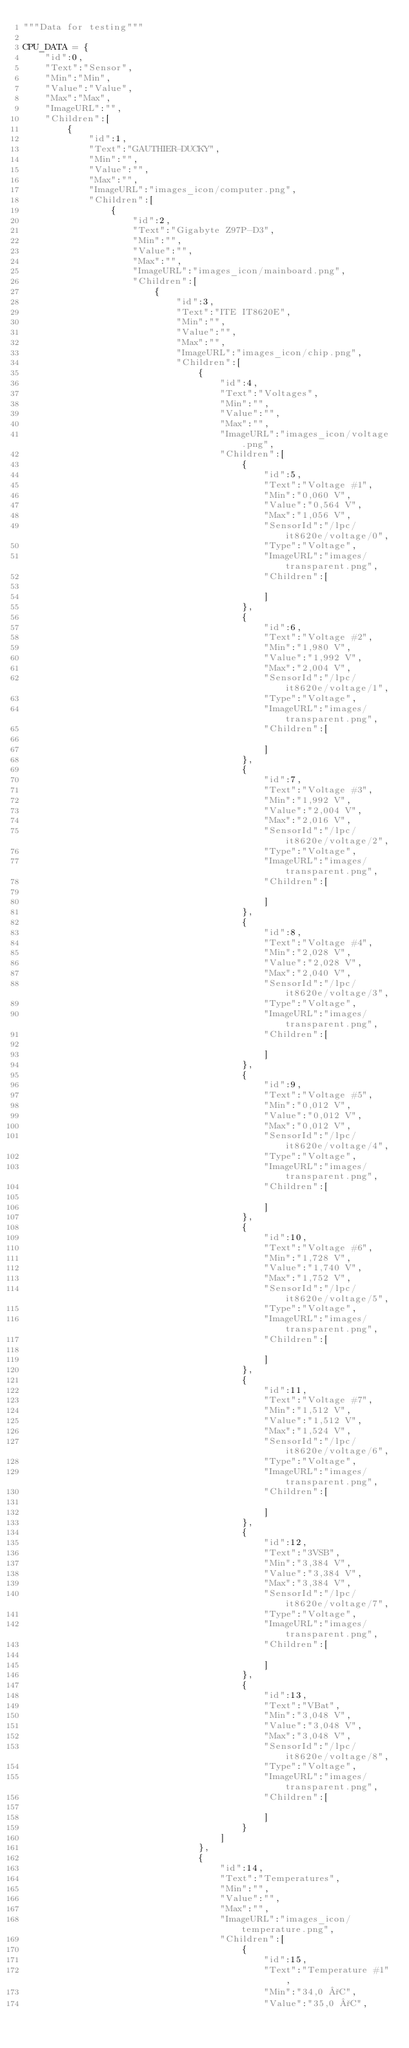<code> <loc_0><loc_0><loc_500><loc_500><_Python_>"""Data for testing"""

CPU_DATA = {
    "id":0,
    "Text":"Sensor",
    "Min":"Min",
    "Value":"Value",
    "Max":"Max",
    "ImageURL":"",
    "Children":[
        {
            "id":1,
            "Text":"GAUTHIER-DUCKY",
            "Min":"",
            "Value":"",
            "Max":"",
            "ImageURL":"images_icon/computer.png",
            "Children":[
                {
                    "id":2,
                    "Text":"Gigabyte Z97P-D3",
                    "Min":"",
                    "Value":"",
                    "Max":"",
                    "ImageURL":"images_icon/mainboard.png",
                    "Children":[
                        {
                            "id":3,
                            "Text":"ITE IT8620E",
                            "Min":"",
                            "Value":"",
                            "Max":"",
                            "ImageURL":"images_icon/chip.png",
                            "Children":[
                                {
                                    "id":4,
                                    "Text":"Voltages",
                                    "Min":"",
                                    "Value":"",
                                    "Max":"",
                                    "ImageURL":"images_icon/voltage.png",
                                    "Children":[
                                        {
                                            "id":5,
                                            "Text":"Voltage #1",
                                            "Min":"0,060 V",
                                            "Value":"0,564 V",
                                            "Max":"1,056 V",
                                            "SensorId":"/lpc/it8620e/voltage/0",
                                            "Type":"Voltage",
                                            "ImageURL":"images/transparent.png",
                                            "Children":[

                                            ]
                                        },
                                        {
                                            "id":6,
                                            "Text":"Voltage #2",
                                            "Min":"1,980 V",
                                            "Value":"1,992 V",
                                            "Max":"2,004 V",
                                            "SensorId":"/lpc/it8620e/voltage/1",
                                            "Type":"Voltage",
                                            "ImageURL":"images/transparent.png",
                                            "Children":[

                                            ]
                                        },
                                        {
                                            "id":7,
                                            "Text":"Voltage #3",
                                            "Min":"1,992 V",
                                            "Value":"2,004 V",
                                            "Max":"2,016 V",
                                            "SensorId":"/lpc/it8620e/voltage/2",
                                            "Type":"Voltage",
                                            "ImageURL":"images/transparent.png",
                                            "Children":[

                                            ]
                                        },
                                        {
                                            "id":8,
                                            "Text":"Voltage #4",
                                            "Min":"2,028 V",
                                            "Value":"2,028 V",
                                            "Max":"2,040 V",
                                            "SensorId":"/lpc/it8620e/voltage/3",
                                            "Type":"Voltage",
                                            "ImageURL":"images/transparent.png",
                                            "Children":[

                                            ]
                                        },
                                        {
                                            "id":9,
                                            "Text":"Voltage #5",
                                            "Min":"0,012 V",
                                            "Value":"0,012 V",
                                            "Max":"0,012 V",
                                            "SensorId":"/lpc/it8620e/voltage/4",
                                            "Type":"Voltage",
                                            "ImageURL":"images/transparent.png",
                                            "Children":[

                                            ]
                                        },
                                        {
                                            "id":10,
                                            "Text":"Voltage #6",
                                            "Min":"1,728 V",
                                            "Value":"1,740 V",
                                            "Max":"1,752 V",
                                            "SensorId":"/lpc/it8620e/voltage/5",
                                            "Type":"Voltage",
                                            "ImageURL":"images/transparent.png",
                                            "Children":[

                                            ]
                                        },
                                        {
                                            "id":11,
                                            "Text":"Voltage #7",
                                            "Min":"1,512 V",
                                            "Value":"1,512 V",
                                            "Max":"1,524 V",
                                            "SensorId":"/lpc/it8620e/voltage/6",
                                            "Type":"Voltage",
                                            "ImageURL":"images/transparent.png",
                                            "Children":[

                                            ]
                                        },
                                        {
                                            "id":12,
                                            "Text":"3VSB",
                                            "Min":"3,384 V",
                                            "Value":"3,384 V",
                                            "Max":"3,384 V",
                                            "SensorId":"/lpc/it8620e/voltage/7",
                                            "Type":"Voltage",
                                            "ImageURL":"images/transparent.png",
                                            "Children":[

                                            ]
                                        },
                                        {
                                            "id":13,
                                            "Text":"VBat",
                                            "Min":"3,048 V",
                                            "Value":"3,048 V",
                                            "Max":"3,048 V",
                                            "SensorId":"/lpc/it8620e/voltage/8",
                                            "Type":"Voltage",
                                            "ImageURL":"images/transparent.png",
                                            "Children":[

                                            ]
                                        }
                                    ]
                                },
                                {
                                    "id":14,
                                    "Text":"Temperatures",
                                    "Min":"",
                                    "Value":"",
                                    "Max":"",
                                    "ImageURL":"images_icon/temperature.png",
                                    "Children":[
                                        {
                                            "id":15,
                                            "Text":"Temperature #1",
                                            "Min":"34,0 °C",
                                            "Value":"35,0 °C",</code> 